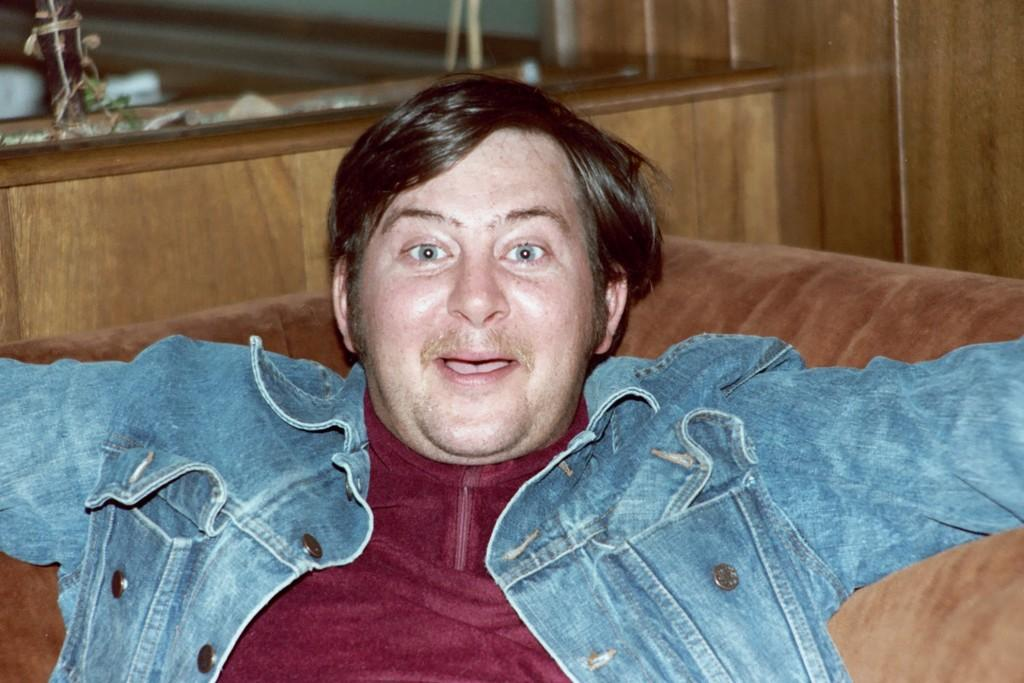Who is present in the image? There is a man in the image. What is the man sitting on? The man is sitting on a brown sofa. What is the man wearing on his upper body? The man is wearing a red T-shirt and a blue jacket. What can be seen in the background of the image? There is a wooden wall in the background of the image. What type of whip is the man holding in the image? There is no whip present in the image; the man is not holding any object. How many thumbs does the man have in the image? The image does not show the man's hands or thumbs, so it cannot be determined from the image. 